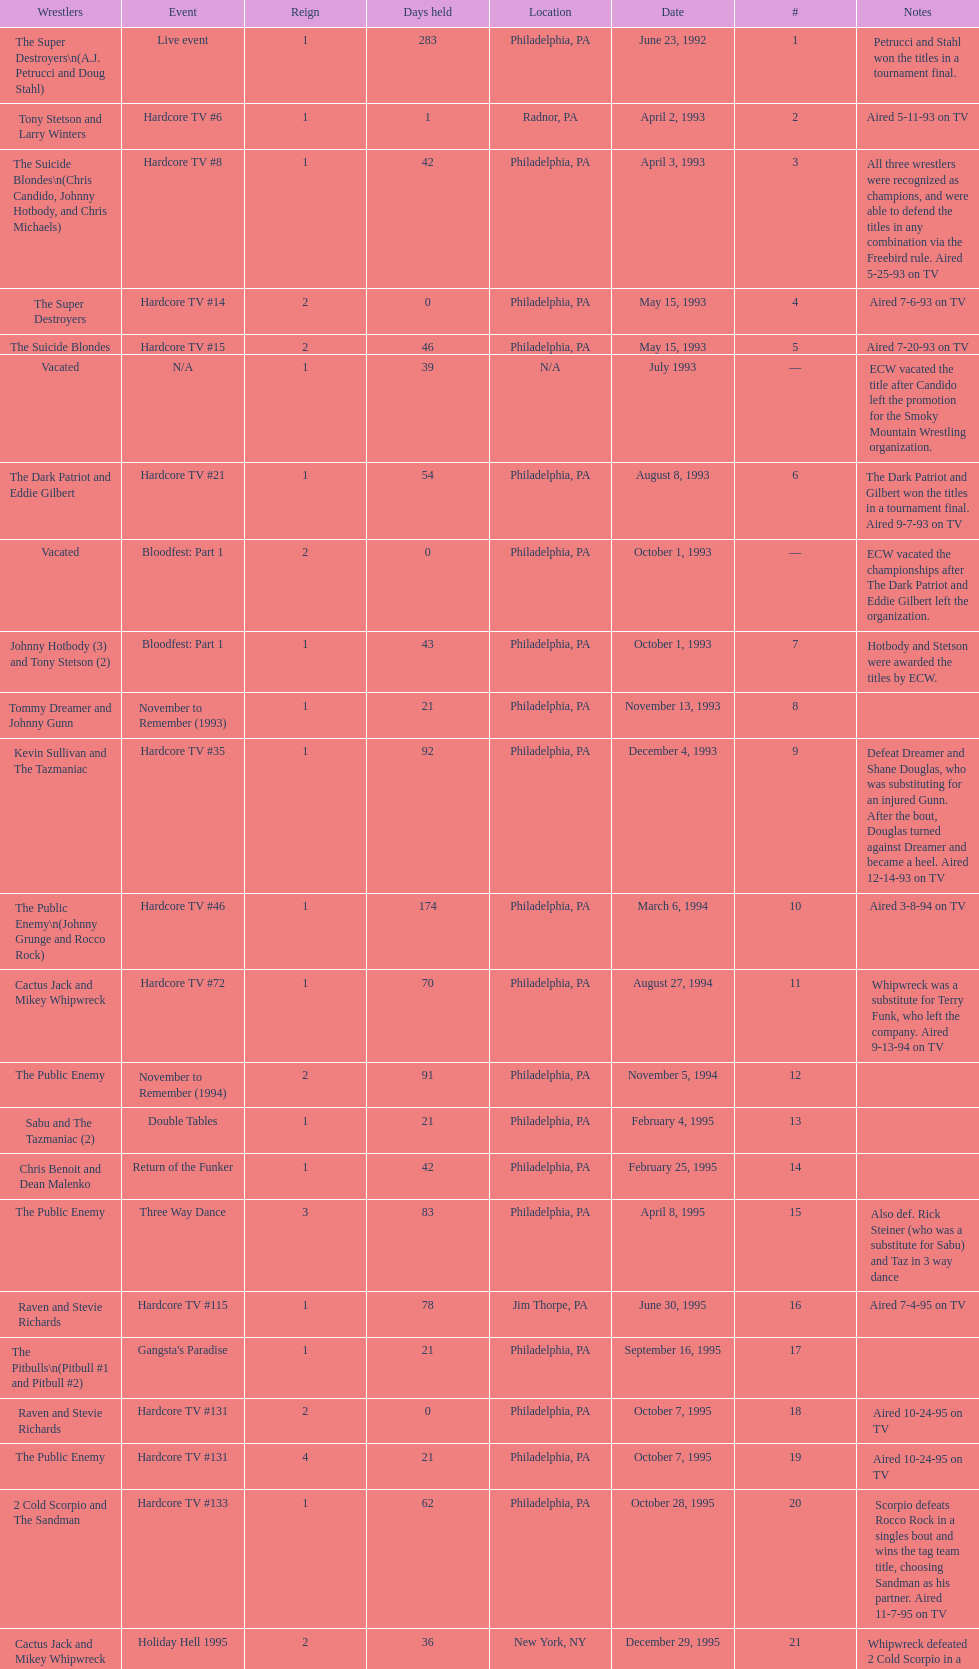How many days did hardcore tv #6 take? 1. 